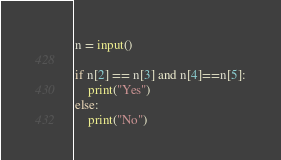<code> <loc_0><loc_0><loc_500><loc_500><_Python_>n = input()

if n[2] == n[3] and n[4]==n[5]:
	print("Yes")
else:
    print("No")</code> 